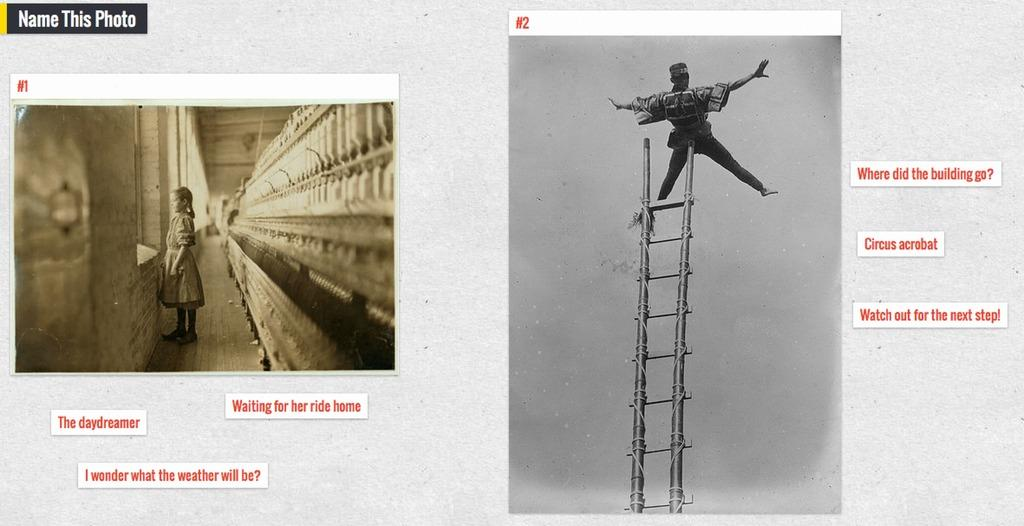Provide a one-sentence caption for the provided image. a sign that says where did the building go on it. 